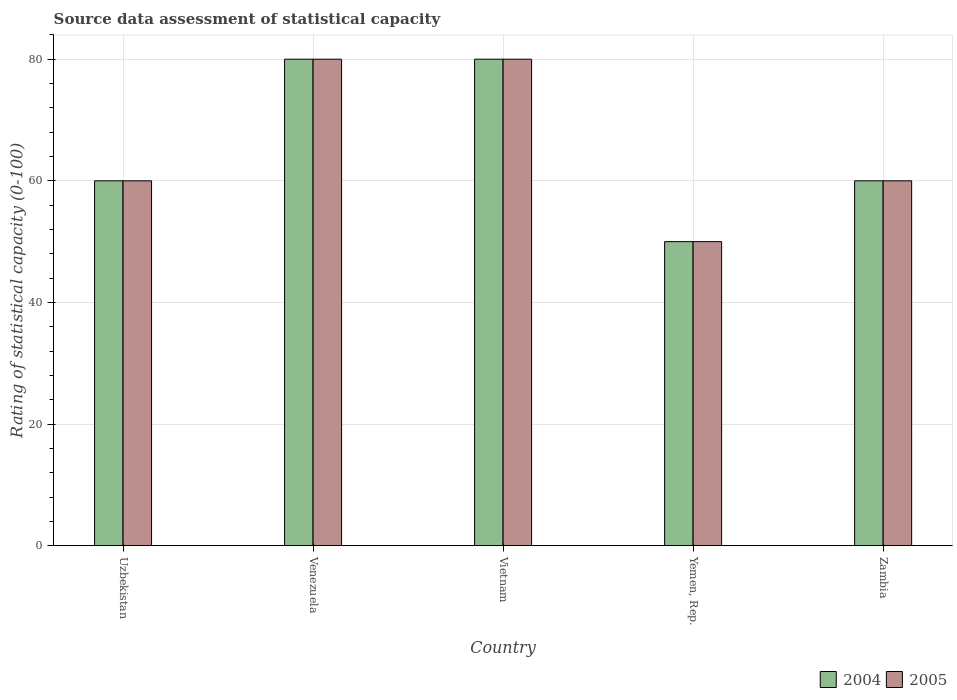Are the number of bars on each tick of the X-axis equal?
Give a very brief answer. Yes. How many bars are there on the 5th tick from the left?
Your response must be concise. 2. What is the label of the 1st group of bars from the left?
Give a very brief answer. Uzbekistan. In how many cases, is the number of bars for a given country not equal to the number of legend labels?
Offer a terse response. 0. What is the rating of statistical capacity in 2005 in Venezuela?
Make the answer very short. 80. Across all countries, what is the minimum rating of statistical capacity in 2004?
Offer a very short reply. 50. In which country was the rating of statistical capacity in 2005 maximum?
Your answer should be compact. Venezuela. In which country was the rating of statistical capacity in 2004 minimum?
Ensure brevity in your answer.  Yemen, Rep. What is the total rating of statistical capacity in 2005 in the graph?
Give a very brief answer. 330. What is the difference between the rating of statistical capacity in 2005 in Vietnam and the rating of statistical capacity in 2004 in Yemen, Rep.?
Your response must be concise. 30. What is the average rating of statistical capacity in 2004 per country?
Keep it short and to the point. 66. What is the ratio of the rating of statistical capacity in 2005 in Venezuela to that in Zambia?
Give a very brief answer. 1.33. Is the rating of statistical capacity in 2005 in Yemen, Rep. less than that in Zambia?
Offer a terse response. Yes. Is the difference between the rating of statistical capacity in 2004 in Yemen, Rep. and Zambia greater than the difference between the rating of statistical capacity in 2005 in Yemen, Rep. and Zambia?
Your answer should be compact. No. What is the difference between the highest and the second highest rating of statistical capacity in 2005?
Offer a terse response. 20. What is the difference between the highest and the lowest rating of statistical capacity in 2004?
Provide a succinct answer. 30. Is the sum of the rating of statistical capacity in 2005 in Venezuela and Zambia greater than the maximum rating of statistical capacity in 2004 across all countries?
Provide a short and direct response. Yes. What does the 1st bar from the right in Vietnam represents?
Keep it short and to the point. 2005. Are all the bars in the graph horizontal?
Make the answer very short. No. Are the values on the major ticks of Y-axis written in scientific E-notation?
Give a very brief answer. No. Does the graph contain any zero values?
Offer a very short reply. No. Does the graph contain grids?
Provide a short and direct response. Yes. How many legend labels are there?
Provide a short and direct response. 2. How are the legend labels stacked?
Your answer should be compact. Horizontal. What is the title of the graph?
Your response must be concise. Source data assessment of statistical capacity. Does "2004" appear as one of the legend labels in the graph?
Give a very brief answer. Yes. What is the label or title of the X-axis?
Your response must be concise. Country. What is the label or title of the Y-axis?
Your answer should be very brief. Rating of statistical capacity (0-100). What is the Rating of statistical capacity (0-100) of 2005 in Uzbekistan?
Make the answer very short. 60. What is the Rating of statistical capacity (0-100) in 2004 in Venezuela?
Offer a very short reply. 80. What is the Rating of statistical capacity (0-100) of 2005 in Venezuela?
Provide a succinct answer. 80. What is the Rating of statistical capacity (0-100) of 2004 in Vietnam?
Offer a terse response. 80. What is the Rating of statistical capacity (0-100) in 2005 in Vietnam?
Provide a short and direct response. 80. What is the Rating of statistical capacity (0-100) of 2004 in Yemen, Rep.?
Offer a very short reply. 50. What is the Rating of statistical capacity (0-100) in 2004 in Zambia?
Provide a succinct answer. 60. Across all countries, what is the maximum Rating of statistical capacity (0-100) in 2004?
Ensure brevity in your answer.  80. Across all countries, what is the minimum Rating of statistical capacity (0-100) in 2004?
Offer a very short reply. 50. What is the total Rating of statistical capacity (0-100) in 2004 in the graph?
Offer a terse response. 330. What is the total Rating of statistical capacity (0-100) of 2005 in the graph?
Your response must be concise. 330. What is the difference between the Rating of statistical capacity (0-100) in 2004 in Uzbekistan and that in Venezuela?
Your answer should be very brief. -20. What is the difference between the Rating of statistical capacity (0-100) in 2004 in Uzbekistan and that in Vietnam?
Offer a terse response. -20. What is the difference between the Rating of statistical capacity (0-100) of 2005 in Uzbekistan and that in Yemen, Rep.?
Provide a succinct answer. 10. What is the difference between the Rating of statistical capacity (0-100) in 2005 in Venezuela and that in Vietnam?
Ensure brevity in your answer.  0. What is the difference between the Rating of statistical capacity (0-100) of 2005 in Venezuela and that in Zambia?
Keep it short and to the point. 20. What is the difference between the Rating of statistical capacity (0-100) in 2004 in Vietnam and that in Yemen, Rep.?
Provide a short and direct response. 30. What is the difference between the Rating of statistical capacity (0-100) of 2005 in Vietnam and that in Zambia?
Make the answer very short. 20. What is the difference between the Rating of statistical capacity (0-100) of 2004 in Uzbekistan and the Rating of statistical capacity (0-100) of 2005 in Vietnam?
Provide a short and direct response. -20. What is the difference between the Rating of statistical capacity (0-100) of 2004 in Uzbekistan and the Rating of statistical capacity (0-100) of 2005 in Yemen, Rep.?
Provide a short and direct response. 10. What is the difference between the Rating of statistical capacity (0-100) in 2004 in Uzbekistan and the Rating of statistical capacity (0-100) in 2005 in Zambia?
Provide a succinct answer. 0. What is the difference between the Rating of statistical capacity (0-100) of 2004 in Venezuela and the Rating of statistical capacity (0-100) of 2005 in Vietnam?
Your answer should be very brief. 0. What is the difference between the Rating of statistical capacity (0-100) of 2004 in Venezuela and the Rating of statistical capacity (0-100) of 2005 in Yemen, Rep.?
Your answer should be very brief. 30. What is the difference between the Rating of statistical capacity (0-100) of 2004 in Venezuela and the Rating of statistical capacity (0-100) of 2005 in Zambia?
Offer a very short reply. 20. What is the difference between the Rating of statistical capacity (0-100) of 2004 in Vietnam and the Rating of statistical capacity (0-100) of 2005 in Yemen, Rep.?
Ensure brevity in your answer.  30. What is the difference between the Rating of statistical capacity (0-100) in 2004 and Rating of statistical capacity (0-100) in 2005 in Uzbekistan?
Offer a very short reply. 0. What is the difference between the Rating of statistical capacity (0-100) in 2004 and Rating of statistical capacity (0-100) in 2005 in Vietnam?
Provide a succinct answer. 0. What is the difference between the Rating of statistical capacity (0-100) of 2004 and Rating of statistical capacity (0-100) of 2005 in Yemen, Rep.?
Provide a short and direct response. 0. What is the ratio of the Rating of statistical capacity (0-100) in 2005 in Uzbekistan to that in Venezuela?
Provide a succinct answer. 0.75. What is the ratio of the Rating of statistical capacity (0-100) in 2004 in Uzbekistan to that in Yemen, Rep.?
Keep it short and to the point. 1.2. What is the ratio of the Rating of statistical capacity (0-100) of 2004 in Uzbekistan to that in Zambia?
Keep it short and to the point. 1. What is the ratio of the Rating of statistical capacity (0-100) in 2005 in Uzbekistan to that in Zambia?
Provide a short and direct response. 1. What is the ratio of the Rating of statistical capacity (0-100) of 2004 in Venezuela to that in Zambia?
Provide a short and direct response. 1.33. What is the ratio of the Rating of statistical capacity (0-100) in 2005 in Vietnam to that in Yemen, Rep.?
Ensure brevity in your answer.  1.6. What is the ratio of the Rating of statistical capacity (0-100) in 2005 in Vietnam to that in Zambia?
Your response must be concise. 1.33. What is the ratio of the Rating of statistical capacity (0-100) of 2004 in Yemen, Rep. to that in Zambia?
Give a very brief answer. 0.83. What is the ratio of the Rating of statistical capacity (0-100) in 2005 in Yemen, Rep. to that in Zambia?
Provide a succinct answer. 0.83. What is the difference between the highest and the second highest Rating of statistical capacity (0-100) of 2004?
Your answer should be very brief. 0. What is the difference between the highest and the lowest Rating of statistical capacity (0-100) in 2004?
Offer a terse response. 30. What is the difference between the highest and the lowest Rating of statistical capacity (0-100) of 2005?
Offer a terse response. 30. 